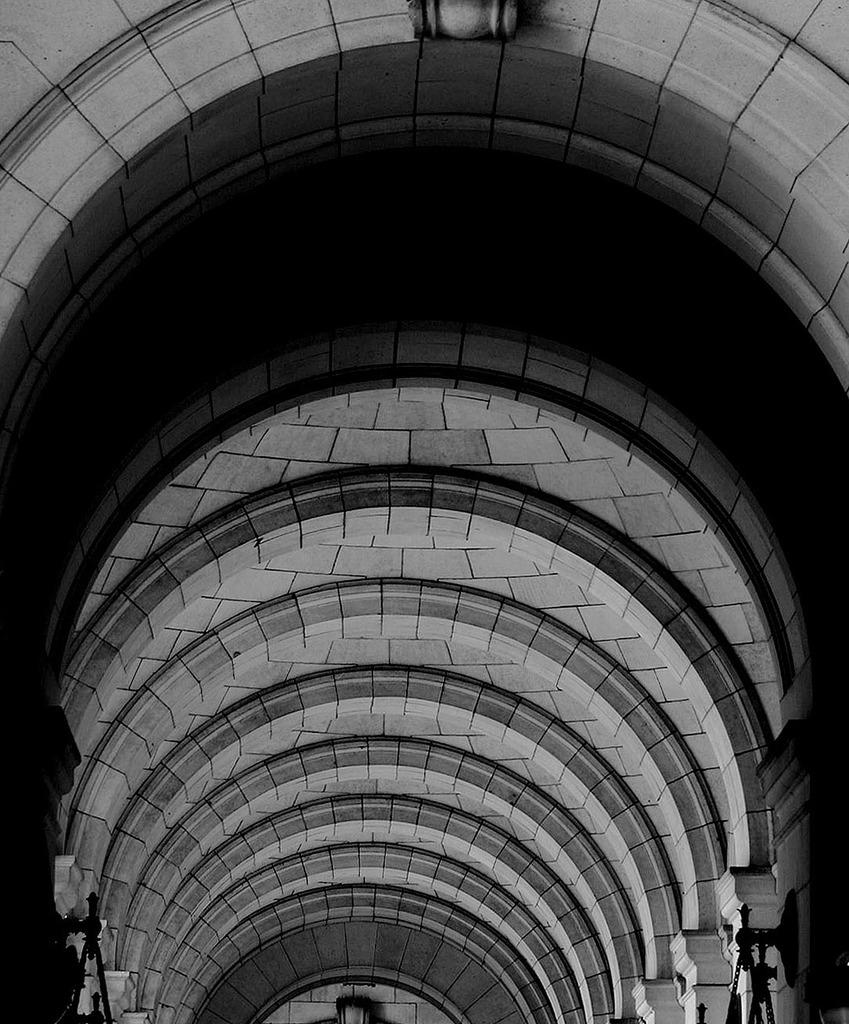What type of view is shown in the image? The image shows an inside view of a building. Can you describe what is visible on both sides of the image? The image is black and white, and there are things visible on both sides. What color is the image? The image is black and white and white in color. What type of trouble can be seen in the image? There is no trouble visible in the image; it shows an inside view of a building with a black and white and white color scheme. How many divisions are present in the image? There is no mention of divisions in the image; it simply shows an inside view of a building with a black and white and white color scheme. 